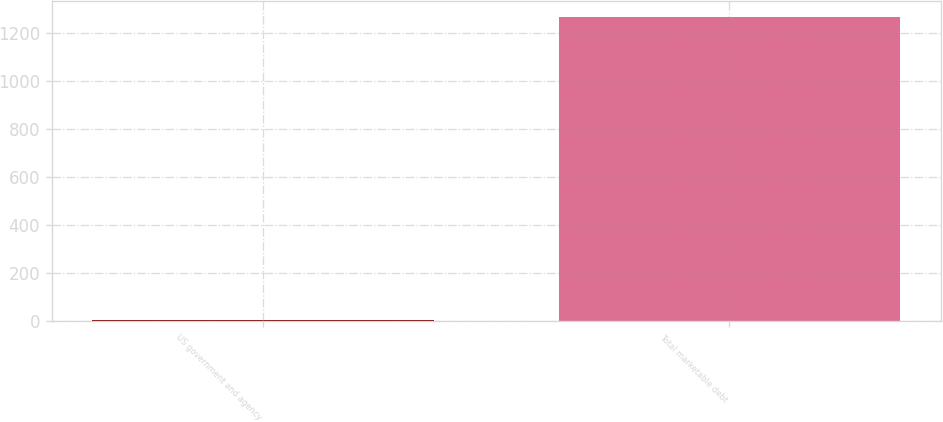<chart> <loc_0><loc_0><loc_500><loc_500><bar_chart><fcel>US government and agency<fcel>Total marketable debt<nl><fcel>5.5<fcel>1267.5<nl></chart> 